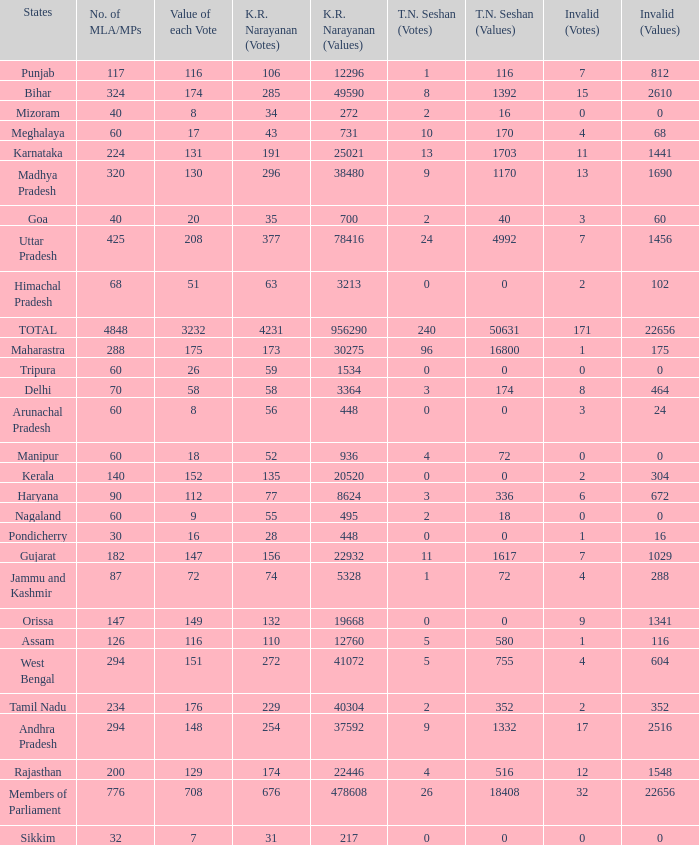Name the most kr votes for value of each vote for 208 377.0. 